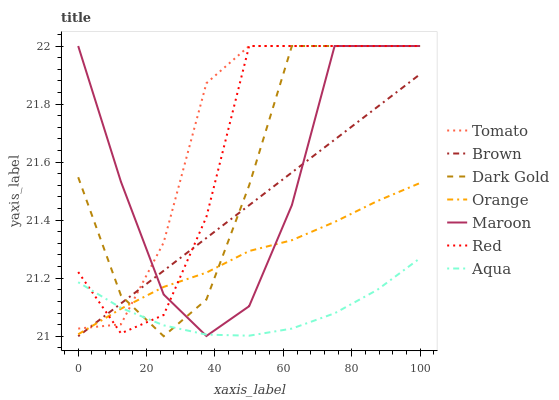Does Aqua have the minimum area under the curve?
Answer yes or no. Yes. Does Tomato have the maximum area under the curve?
Answer yes or no. Yes. Does Brown have the minimum area under the curve?
Answer yes or no. No. Does Brown have the maximum area under the curve?
Answer yes or no. No. Is Brown the smoothest?
Answer yes or no. Yes. Is Maroon the roughest?
Answer yes or no. Yes. Is Dark Gold the smoothest?
Answer yes or no. No. Is Dark Gold the roughest?
Answer yes or no. No. Does Brown have the lowest value?
Answer yes or no. Yes. Does Dark Gold have the lowest value?
Answer yes or no. No. Does Red have the highest value?
Answer yes or no. Yes. Does Brown have the highest value?
Answer yes or no. No. Does Dark Gold intersect Orange?
Answer yes or no. Yes. Is Dark Gold less than Orange?
Answer yes or no. No. Is Dark Gold greater than Orange?
Answer yes or no. No. 